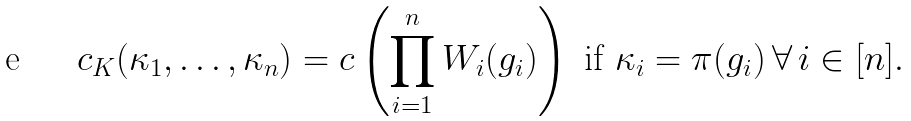Convert formula to latex. <formula><loc_0><loc_0><loc_500><loc_500>c _ { K } ( \kappa _ { 1 } , \dots , \kappa _ { n } ) = c \left ( \prod _ { i = 1 } ^ { n } W _ { i } ( g _ { i } ) \right ) \text { if } \kappa _ { i } = \pi ( g _ { i } ) \, \forall \, i \in [ n ] .</formula> 